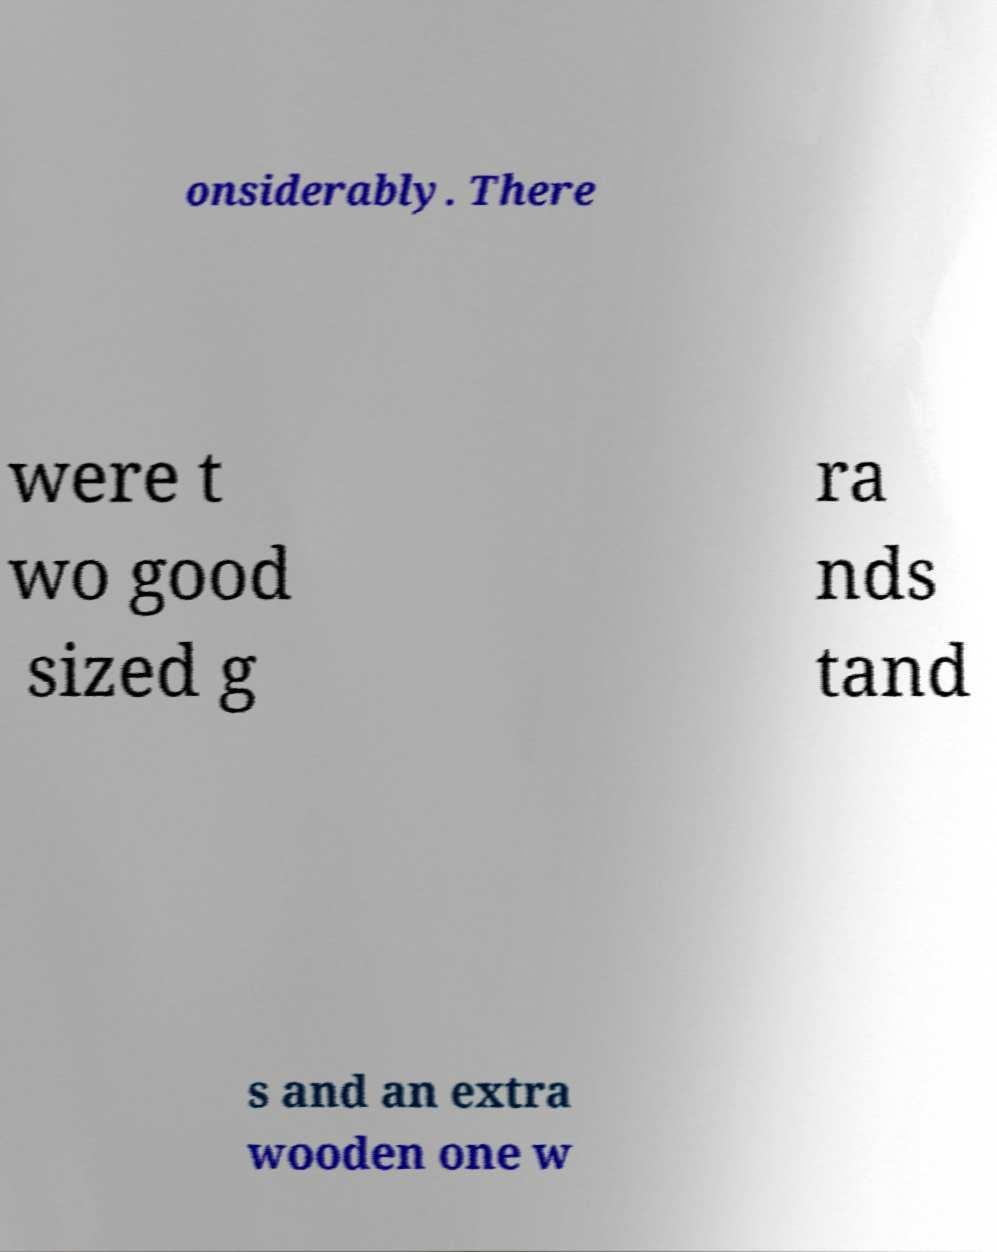Could you extract and type out the text from this image? onsiderably. There were t wo good sized g ra nds tand s and an extra wooden one w 